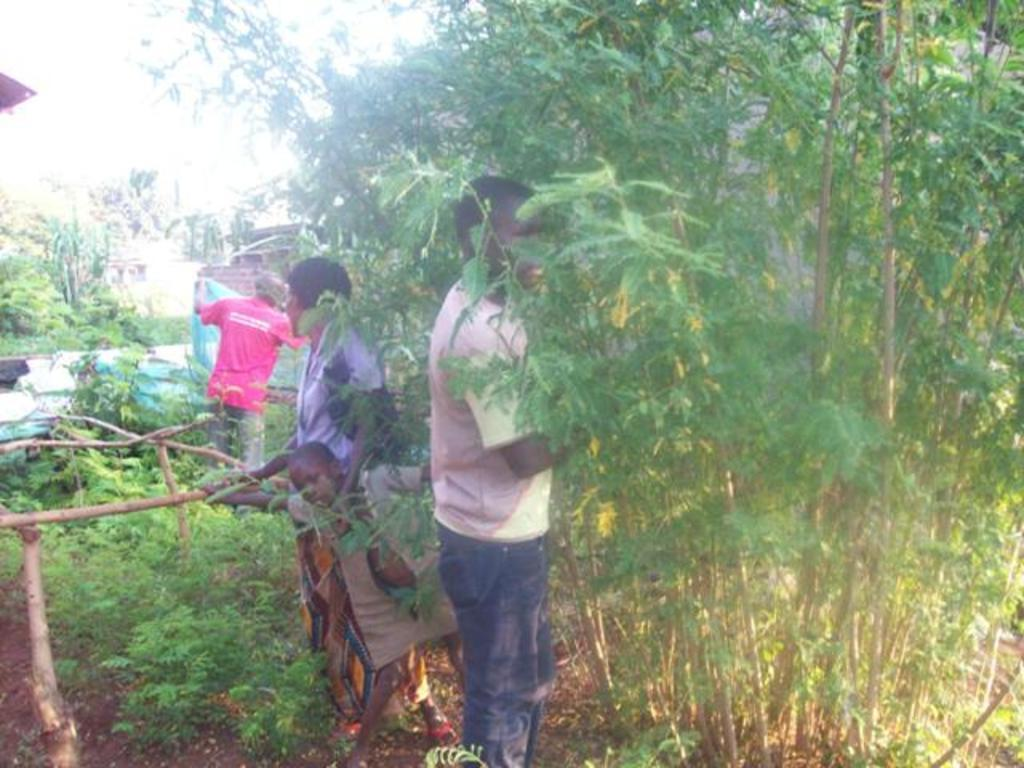How many people are in the image? There are four people standing in the middle of the image. What can be seen in the background of the image? There are trees in the background of the image. What is visible at the top of the image? The sky is visible at the top of the image. What time is displayed on the clock in the image? There is no clock present in the image. Can you describe the elbow of the person on the left in the image? There is no specific person mentioned in the image, and no elbows are visible or described in the provided facts. 